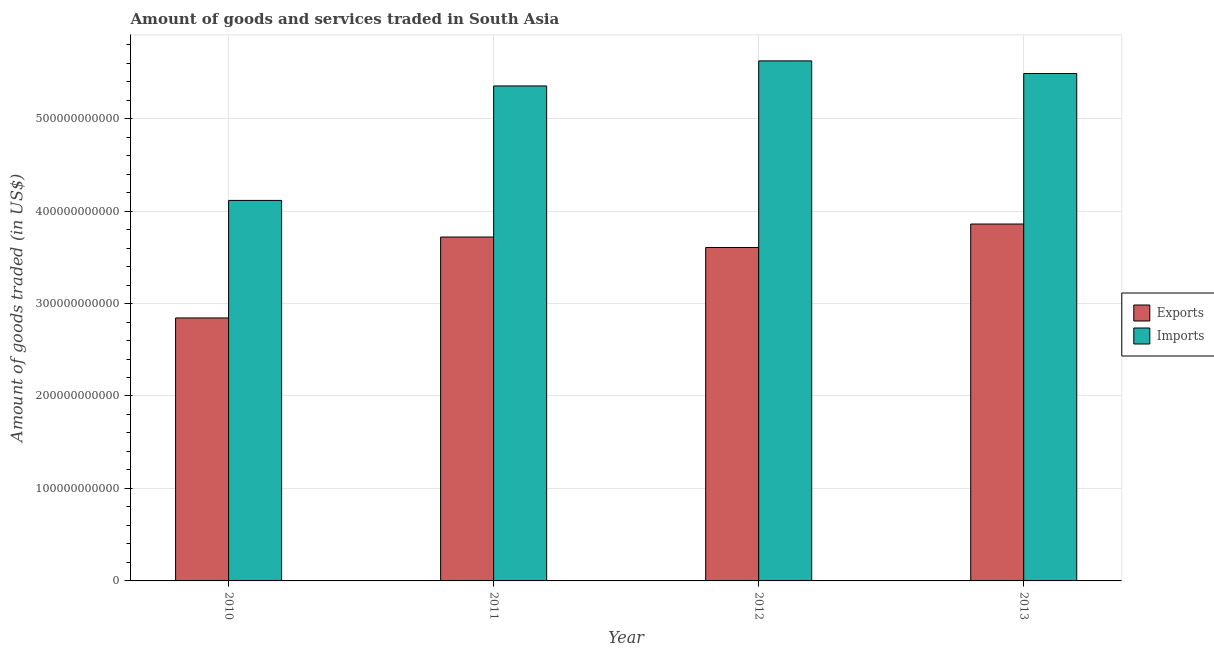How many bars are there on the 3rd tick from the left?
Offer a terse response. 2. In how many cases, is the number of bars for a given year not equal to the number of legend labels?
Your answer should be compact. 0. What is the amount of goods imported in 2013?
Provide a succinct answer. 5.49e+11. Across all years, what is the maximum amount of goods imported?
Offer a terse response. 5.62e+11. Across all years, what is the minimum amount of goods exported?
Give a very brief answer. 2.84e+11. What is the total amount of goods imported in the graph?
Offer a very short reply. 2.06e+12. What is the difference between the amount of goods exported in 2010 and that in 2012?
Give a very brief answer. -7.62e+1. What is the difference between the amount of goods imported in 2011 and the amount of goods exported in 2010?
Give a very brief answer. 1.24e+11. What is the average amount of goods imported per year?
Make the answer very short. 5.14e+11. In the year 2012, what is the difference between the amount of goods exported and amount of goods imported?
Ensure brevity in your answer.  0. What is the ratio of the amount of goods exported in 2011 to that in 2013?
Provide a succinct answer. 0.96. Is the amount of goods imported in 2010 less than that in 2011?
Provide a succinct answer. Yes. What is the difference between the highest and the second highest amount of goods exported?
Your response must be concise. 1.41e+1. What is the difference between the highest and the lowest amount of goods exported?
Ensure brevity in your answer.  1.02e+11. In how many years, is the amount of goods exported greater than the average amount of goods exported taken over all years?
Give a very brief answer. 3. What does the 2nd bar from the left in 2011 represents?
Provide a succinct answer. Imports. What does the 2nd bar from the right in 2012 represents?
Your answer should be compact. Exports. How many bars are there?
Your answer should be very brief. 8. How many years are there in the graph?
Offer a terse response. 4. What is the difference between two consecutive major ticks on the Y-axis?
Provide a succinct answer. 1.00e+11. Does the graph contain grids?
Ensure brevity in your answer.  Yes. Where does the legend appear in the graph?
Provide a succinct answer. Center right. How are the legend labels stacked?
Provide a succinct answer. Vertical. What is the title of the graph?
Your answer should be compact. Amount of goods and services traded in South Asia. What is the label or title of the X-axis?
Make the answer very short. Year. What is the label or title of the Y-axis?
Keep it short and to the point. Amount of goods traded (in US$). What is the Amount of goods traded (in US$) in Exports in 2010?
Give a very brief answer. 2.84e+11. What is the Amount of goods traded (in US$) of Imports in 2010?
Offer a terse response. 4.12e+11. What is the Amount of goods traded (in US$) of Exports in 2011?
Your response must be concise. 3.72e+11. What is the Amount of goods traded (in US$) in Imports in 2011?
Provide a short and direct response. 5.35e+11. What is the Amount of goods traded (in US$) of Exports in 2012?
Make the answer very short. 3.61e+11. What is the Amount of goods traded (in US$) in Imports in 2012?
Give a very brief answer. 5.62e+11. What is the Amount of goods traded (in US$) of Exports in 2013?
Your answer should be compact. 3.86e+11. What is the Amount of goods traded (in US$) in Imports in 2013?
Keep it short and to the point. 5.49e+11. Across all years, what is the maximum Amount of goods traded (in US$) in Exports?
Provide a short and direct response. 3.86e+11. Across all years, what is the maximum Amount of goods traded (in US$) in Imports?
Make the answer very short. 5.62e+11. Across all years, what is the minimum Amount of goods traded (in US$) in Exports?
Make the answer very short. 2.84e+11. Across all years, what is the minimum Amount of goods traded (in US$) in Imports?
Keep it short and to the point. 4.12e+11. What is the total Amount of goods traded (in US$) in Exports in the graph?
Provide a short and direct response. 1.40e+12. What is the total Amount of goods traded (in US$) of Imports in the graph?
Keep it short and to the point. 2.06e+12. What is the difference between the Amount of goods traded (in US$) in Exports in 2010 and that in 2011?
Provide a short and direct response. -8.75e+1. What is the difference between the Amount of goods traded (in US$) in Imports in 2010 and that in 2011?
Offer a terse response. -1.24e+11. What is the difference between the Amount of goods traded (in US$) of Exports in 2010 and that in 2012?
Give a very brief answer. -7.62e+1. What is the difference between the Amount of goods traded (in US$) in Imports in 2010 and that in 2012?
Provide a short and direct response. -1.51e+11. What is the difference between the Amount of goods traded (in US$) in Exports in 2010 and that in 2013?
Offer a very short reply. -1.02e+11. What is the difference between the Amount of goods traded (in US$) of Imports in 2010 and that in 2013?
Your response must be concise. -1.37e+11. What is the difference between the Amount of goods traded (in US$) in Exports in 2011 and that in 2012?
Give a very brief answer. 1.13e+1. What is the difference between the Amount of goods traded (in US$) in Imports in 2011 and that in 2012?
Offer a terse response. -2.71e+1. What is the difference between the Amount of goods traded (in US$) in Exports in 2011 and that in 2013?
Provide a short and direct response. -1.41e+1. What is the difference between the Amount of goods traded (in US$) of Imports in 2011 and that in 2013?
Your response must be concise. -1.34e+1. What is the difference between the Amount of goods traded (in US$) of Exports in 2012 and that in 2013?
Keep it short and to the point. -2.54e+1. What is the difference between the Amount of goods traded (in US$) of Imports in 2012 and that in 2013?
Your answer should be compact. 1.37e+1. What is the difference between the Amount of goods traded (in US$) in Exports in 2010 and the Amount of goods traded (in US$) in Imports in 2011?
Make the answer very short. -2.51e+11. What is the difference between the Amount of goods traded (in US$) of Exports in 2010 and the Amount of goods traded (in US$) of Imports in 2012?
Offer a terse response. -2.78e+11. What is the difference between the Amount of goods traded (in US$) in Exports in 2010 and the Amount of goods traded (in US$) in Imports in 2013?
Provide a short and direct response. -2.64e+11. What is the difference between the Amount of goods traded (in US$) of Exports in 2011 and the Amount of goods traded (in US$) of Imports in 2012?
Keep it short and to the point. -1.90e+11. What is the difference between the Amount of goods traded (in US$) in Exports in 2011 and the Amount of goods traded (in US$) in Imports in 2013?
Your answer should be compact. -1.77e+11. What is the difference between the Amount of goods traded (in US$) of Exports in 2012 and the Amount of goods traded (in US$) of Imports in 2013?
Give a very brief answer. -1.88e+11. What is the average Amount of goods traded (in US$) of Exports per year?
Your answer should be compact. 3.51e+11. What is the average Amount of goods traded (in US$) of Imports per year?
Provide a short and direct response. 5.14e+11. In the year 2010, what is the difference between the Amount of goods traded (in US$) in Exports and Amount of goods traded (in US$) in Imports?
Your answer should be very brief. -1.27e+11. In the year 2011, what is the difference between the Amount of goods traded (in US$) of Exports and Amount of goods traded (in US$) of Imports?
Make the answer very short. -1.63e+11. In the year 2012, what is the difference between the Amount of goods traded (in US$) in Exports and Amount of goods traded (in US$) in Imports?
Offer a very short reply. -2.02e+11. In the year 2013, what is the difference between the Amount of goods traded (in US$) in Exports and Amount of goods traded (in US$) in Imports?
Give a very brief answer. -1.63e+11. What is the ratio of the Amount of goods traded (in US$) of Exports in 2010 to that in 2011?
Make the answer very short. 0.76. What is the ratio of the Amount of goods traded (in US$) of Imports in 2010 to that in 2011?
Ensure brevity in your answer.  0.77. What is the ratio of the Amount of goods traded (in US$) of Exports in 2010 to that in 2012?
Your response must be concise. 0.79. What is the ratio of the Amount of goods traded (in US$) of Imports in 2010 to that in 2012?
Make the answer very short. 0.73. What is the ratio of the Amount of goods traded (in US$) of Exports in 2010 to that in 2013?
Keep it short and to the point. 0.74. What is the ratio of the Amount of goods traded (in US$) of Imports in 2010 to that in 2013?
Provide a succinct answer. 0.75. What is the ratio of the Amount of goods traded (in US$) of Exports in 2011 to that in 2012?
Offer a terse response. 1.03. What is the ratio of the Amount of goods traded (in US$) of Imports in 2011 to that in 2012?
Your answer should be compact. 0.95. What is the ratio of the Amount of goods traded (in US$) of Exports in 2011 to that in 2013?
Provide a succinct answer. 0.96. What is the ratio of the Amount of goods traded (in US$) of Imports in 2011 to that in 2013?
Provide a succinct answer. 0.98. What is the ratio of the Amount of goods traded (in US$) in Exports in 2012 to that in 2013?
Ensure brevity in your answer.  0.93. What is the ratio of the Amount of goods traded (in US$) of Imports in 2012 to that in 2013?
Make the answer very short. 1.02. What is the difference between the highest and the second highest Amount of goods traded (in US$) in Exports?
Your answer should be very brief. 1.41e+1. What is the difference between the highest and the second highest Amount of goods traded (in US$) in Imports?
Give a very brief answer. 1.37e+1. What is the difference between the highest and the lowest Amount of goods traded (in US$) in Exports?
Offer a terse response. 1.02e+11. What is the difference between the highest and the lowest Amount of goods traded (in US$) in Imports?
Give a very brief answer. 1.51e+11. 